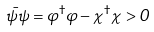<formula> <loc_0><loc_0><loc_500><loc_500>\bar { \psi } \psi = \varphi ^ { \dag } \varphi - \chi ^ { \dag } \chi > 0</formula> 